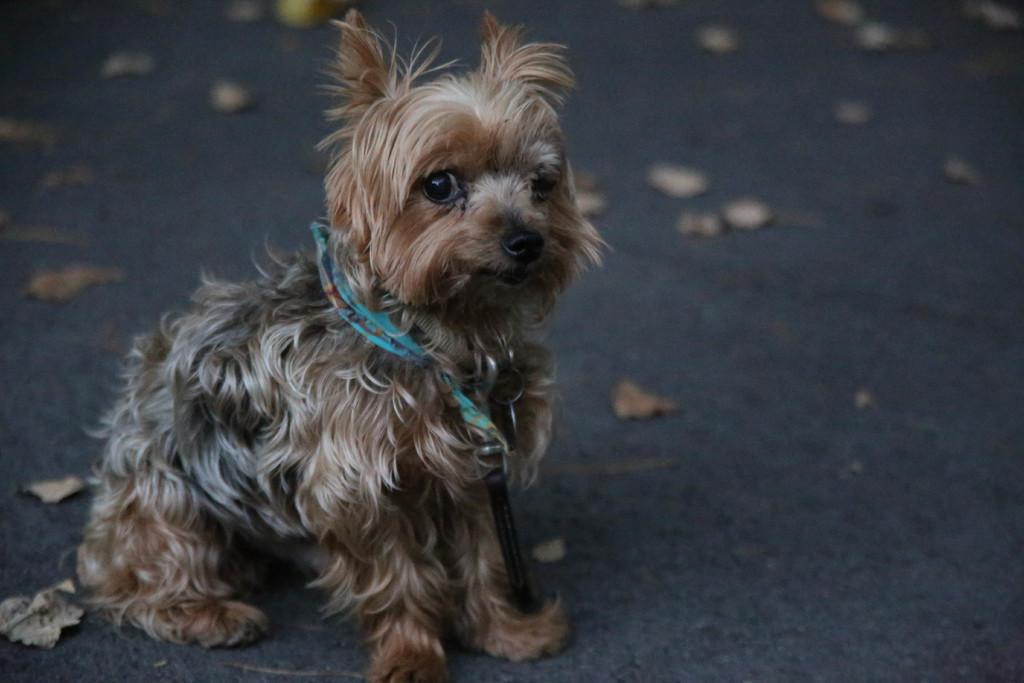What type of animal can be seen in the image? There is a dog in the image. What is visible beneath the dog's feet? The ground is visible in the image. What can be found on the ground in the image? There are dried leaves on the ground. How many brothers does the dog have in the image? There is no information about the dog's brothers in the image. 